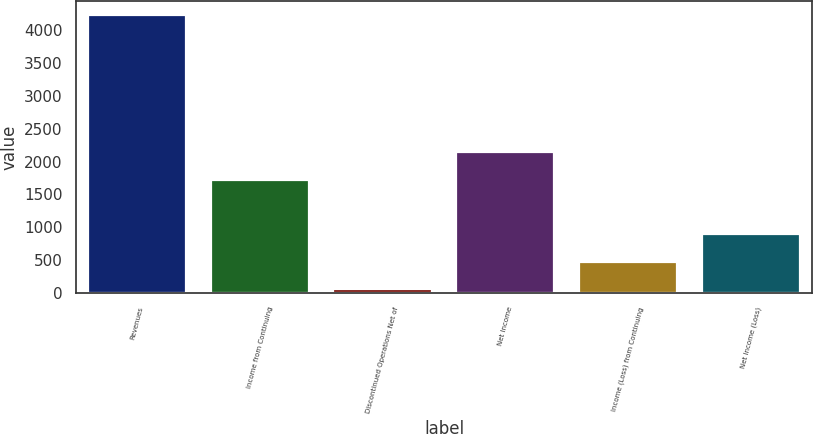Convert chart. <chart><loc_0><loc_0><loc_500><loc_500><bar_chart><fcel>Revenues<fcel>Income from Continuing<fcel>Discontinued Operations Net of<fcel>Net Income<fcel>Income (Loss) from Continuing<fcel>Net Income (Loss)<nl><fcel>4223<fcel>1726.4<fcel>62<fcel>2142.5<fcel>478.1<fcel>894.2<nl></chart> 